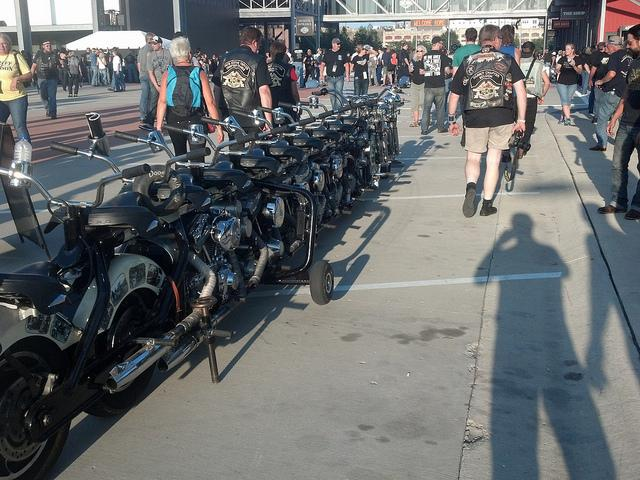What event will the people participate in?

Choices:
A) motorcycle parade
B) marathon
C) protest
D) touring motorcycle parade 